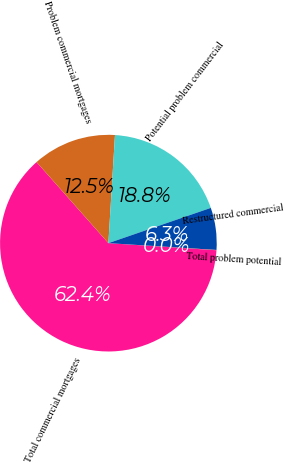<chart> <loc_0><loc_0><loc_500><loc_500><pie_chart><fcel>Total commercial mortgages<fcel>Problem commercial mortgages<fcel>Potential problem commercial<fcel>Restructured commercial<fcel>Total problem potential<nl><fcel>62.42%<fcel>12.51%<fcel>18.75%<fcel>6.28%<fcel>0.04%<nl></chart> 